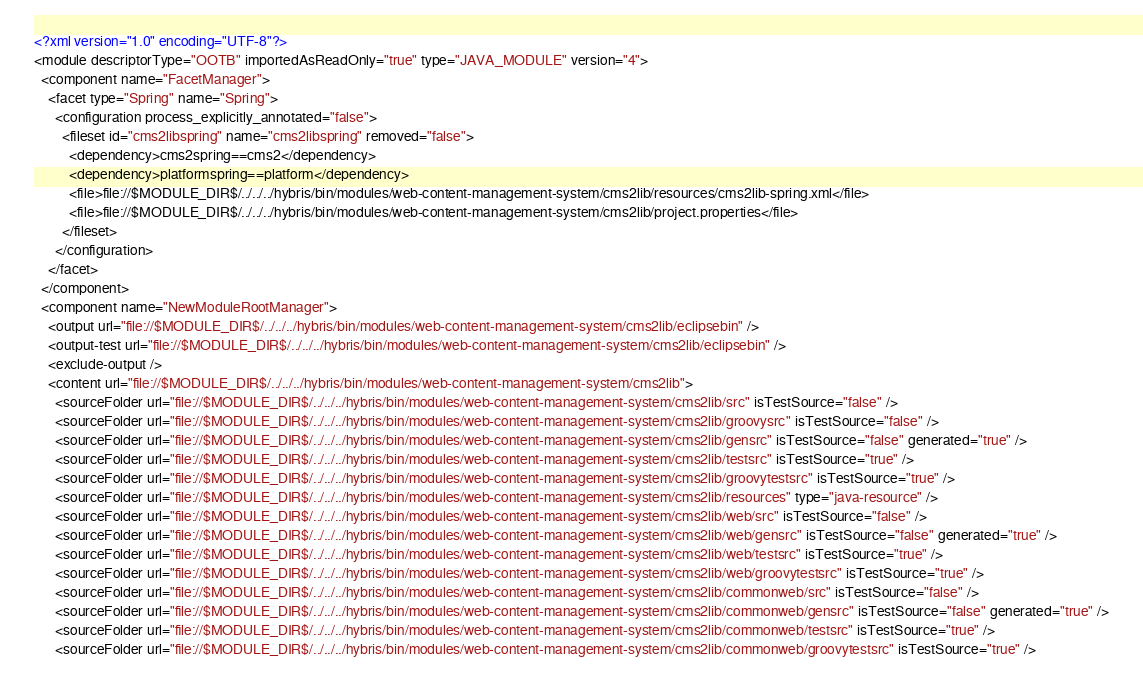Convert code to text. <code><loc_0><loc_0><loc_500><loc_500><_XML_><?xml version="1.0" encoding="UTF-8"?>
<module descriptorType="OOTB" importedAsReadOnly="true" type="JAVA_MODULE" version="4">
  <component name="FacetManager">
    <facet type="Spring" name="Spring">
      <configuration process_explicitly_annotated="false">
        <fileset id="cms2libspring" name="cms2libspring" removed="false">
          <dependency>cms2spring==cms2</dependency>
          <dependency>platformspring==platform</dependency>
          <file>file://$MODULE_DIR$/../../../hybris/bin/modules/web-content-management-system/cms2lib/resources/cms2lib-spring.xml</file>
          <file>file://$MODULE_DIR$/../../../hybris/bin/modules/web-content-management-system/cms2lib/project.properties</file>
        </fileset>
      </configuration>
    </facet>
  </component>
  <component name="NewModuleRootManager">
    <output url="file://$MODULE_DIR$/../../../hybris/bin/modules/web-content-management-system/cms2lib/eclipsebin" />
    <output-test url="file://$MODULE_DIR$/../../../hybris/bin/modules/web-content-management-system/cms2lib/eclipsebin" />
    <exclude-output />
    <content url="file://$MODULE_DIR$/../../../hybris/bin/modules/web-content-management-system/cms2lib">
      <sourceFolder url="file://$MODULE_DIR$/../../../hybris/bin/modules/web-content-management-system/cms2lib/src" isTestSource="false" />
      <sourceFolder url="file://$MODULE_DIR$/../../../hybris/bin/modules/web-content-management-system/cms2lib/groovysrc" isTestSource="false" />
      <sourceFolder url="file://$MODULE_DIR$/../../../hybris/bin/modules/web-content-management-system/cms2lib/gensrc" isTestSource="false" generated="true" />
      <sourceFolder url="file://$MODULE_DIR$/../../../hybris/bin/modules/web-content-management-system/cms2lib/testsrc" isTestSource="true" />
      <sourceFolder url="file://$MODULE_DIR$/../../../hybris/bin/modules/web-content-management-system/cms2lib/groovytestsrc" isTestSource="true" />
      <sourceFolder url="file://$MODULE_DIR$/../../../hybris/bin/modules/web-content-management-system/cms2lib/resources" type="java-resource" />
      <sourceFolder url="file://$MODULE_DIR$/../../../hybris/bin/modules/web-content-management-system/cms2lib/web/src" isTestSource="false" />
      <sourceFolder url="file://$MODULE_DIR$/../../../hybris/bin/modules/web-content-management-system/cms2lib/web/gensrc" isTestSource="false" generated="true" />
      <sourceFolder url="file://$MODULE_DIR$/../../../hybris/bin/modules/web-content-management-system/cms2lib/web/testsrc" isTestSource="true" />
      <sourceFolder url="file://$MODULE_DIR$/../../../hybris/bin/modules/web-content-management-system/cms2lib/web/groovytestsrc" isTestSource="true" />
      <sourceFolder url="file://$MODULE_DIR$/../../../hybris/bin/modules/web-content-management-system/cms2lib/commonweb/src" isTestSource="false" />
      <sourceFolder url="file://$MODULE_DIR$/../../../hybris/bin/modules/web-content-management-system/cms2lib/commonweb/gensrc" isTestSource="false" generated="true" />
      <sourceFolder url="file://$MODULE_DIR$/../../../hybris/bin/modules/web-content-management-system/cms2lib/commonweb/testsrc" isTestSource="true" />
      <sourceFolder url="file://$MODULE_DIR$/../../../hybris/bin/modules/web-content-management-system/cms2lib/commonweb/groovytestsrc" isTestSource="true" /></code> 